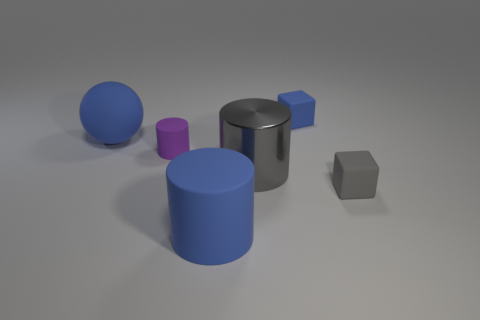Add 1 large gray metallic cylinders. How many objects exist? 7 Subtract all gray cylinders. How many cylinders are left? 2 Subtract all small purple rubber cylinders. How many cylinders are left? 2 Subtract all blocks. How many objects are left? 4 Subtract all gray metallic things. Subtract all gray matte cubes. How many objects are left? 4 Add 3 gray blocks. How many gray blocks are left? 4 Add 4 big cyan rubber cylinders. How many big cyan rubber cylinders exist? 4 Subtract 0 purple blocks. How many objects are left? 6 Subtract 3 cylinders. How many cylinders are left? 0 Subtract all gray balls. Subtract all purple cubes. How many balls are left? 1 